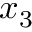Convert formula to latex. <formula><loc_0><loc_0><loc_500><loc_500>x _ { 3 }</formula> 